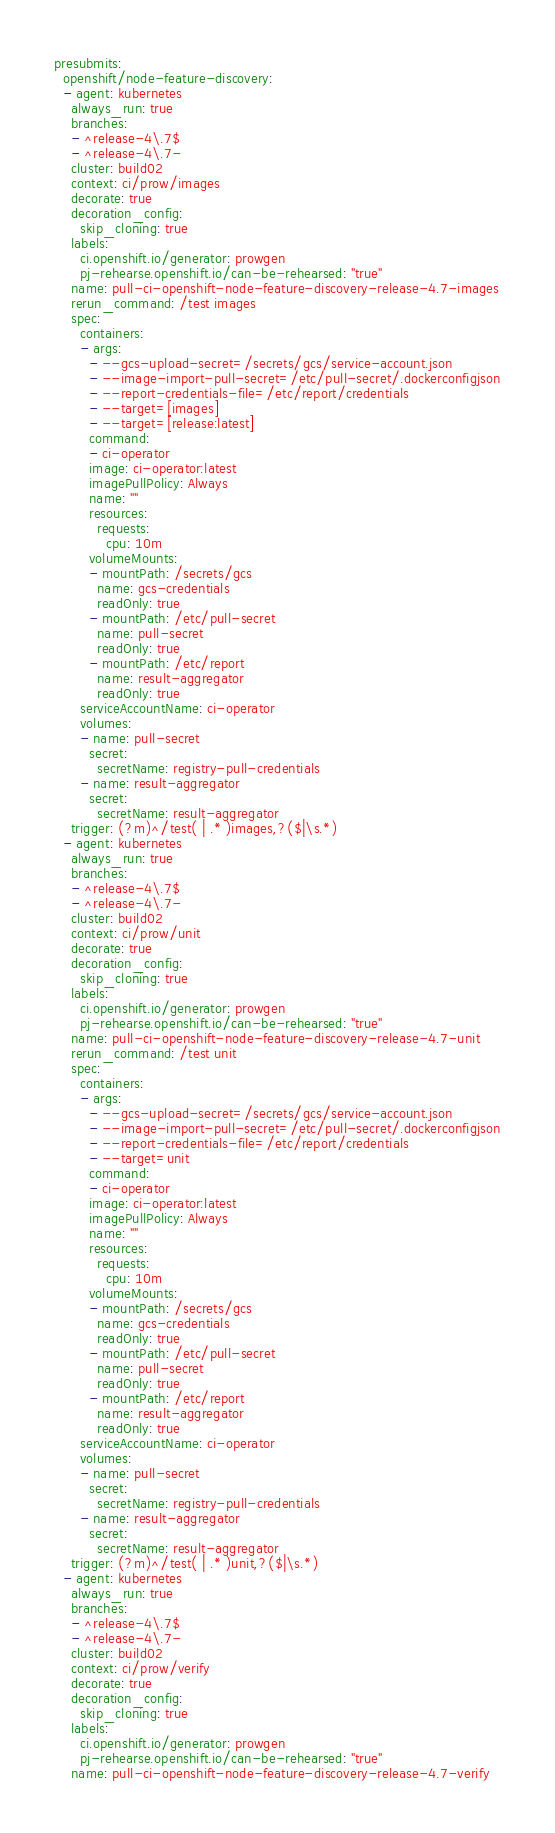Convert code to text. <code><loc_0><loc_0><loc_500><loc_500><_YAML_>presubmits:
  openshift/node-feature-discovery:
  - agent: kubernetes
    always_run: true
    branches:
    - ^release-4\.7$
    - ^release-4\.7-
    cluster: build02
    context: ci/prow/images
    decorate: true
    decoration_config:
      skip_cloning: true
    labels:
      ci.openshift.io/generator: prowgen
      pj-rehearse.openshift.io/can-be-rehearsed: "true"
    name: pull-ci-openshift-node-feature-discovery-release-4.7-images
    rerun_command: /test images
    spec:
      containers:
      - args:
        - --gcs-upload-secret=/secrets/gcs/service-account.json
        - --image-import-pull-secret=/etc/pull-secret/.dockerconfigjson
        - --report-credentials-file=/etc/report/credentials
        - --target=[images]
        - --target=[release:latest]
        command:
        - ci-operator
        image: ci-operator:latest
        imagePullPolicy: Always
        name: ""
        resources:
          requests:
            cpu: 10m
        volumeMounts:
        - mountPath: /secrets/gcs
          name: gcs-credentials
          readOnly: true
        - mountPath: /etc/pull-secret
          name: pull-secret
          readOnly: true
        - mountPath: /etc/report
          name: result-aggregator
          readOnly: true
      serviceAccountName: ci-operator
      volumes:
      - name: pull-secret
        secret:
          secretName: registry-pull-credentials
      - name: result-aggregator
        secret:
          secretName: result-aggregator
    trigger: (?m)^/test( | .* )images,?($|\s.*)
  - agent: kubernetes
    always_run: true
    branches:
    - ^release-4\.7$
    - ^release-4\.7-
    cluster: build02
    context: ci/prow/unit
    decorate: true
    decoration_config:
      skip_cloning: true
    labels:
      ci.openshift.io/generator: prowgen
      pj-rehearse.openshift.io/can-be-rehearsed: "true"
    name: pull-ci-openshift-node-feature-discovery-release-4.7-unit
    rerun_command: /test unit
    spec:
      containers:
      - args:
        - --gcs-upload-secret=/secrets/gcs/service-account.json
        - --image-import-pull-secret=/etc/pull-secret/.dockerconfigjson
        - --report-credentials-file=/etc/report/credentials
        - --target=unit
        command:
        - ci-operator
        image: ci-operator:latest
        imagePullPolicy: Always
        name: ""
        resources:
          requests:
            cpu: 10m
        volumeMounts:
        - mountPath: /secrets/gcs
          name: gcs-credentials
          readOnly: true
        - mountPath: /etc/pull-secret
          name: pull-secret
          readOnly: true
        - mountPath: /etc/report
          name: result-aggregator
          readOnly: true
      serviceAccountName: ci-operator
      volumes:
      - name: pull-secret
        secret:
          secretName: registry-pull-credentials
      - name: result-aggregator
        secret:
          secretName: result-aggregator
    trigger: (?m)^/test( | .* )unit,?($|\s.*)
  - agent: kubernetes
    always_run: true
    branches:
    - ^release-4\.7$
    - ^release-4\.7-
    cluster: build02
    context: ci/prow/verify
    decorate: true
    decoration_config:
      skip_cloning: true
    labels:
      ci.openshift.io/generator: prowgen
      pj-rehearse.openshift.io/can-be-rehearsed: "true"
    name: pull-ci-openshift-node-feature-discovery-release-4.7-verify</code> 